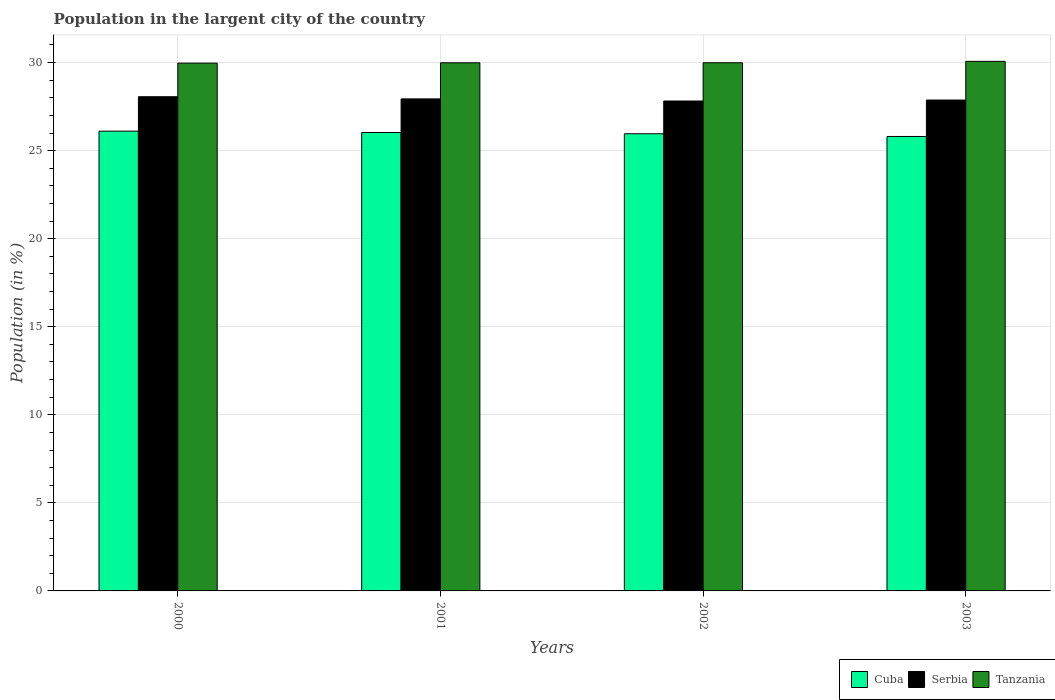How many different coloured bars are there?
Give a very brief answer. 3. Are the number of bars on each tick of the X-axis equal?
Your response must be concise. Yes. How many bars are there on the 2nd tick from the right?
Offer a terse response. 3. What is the label of the 1st group of bars from the left?
Your answer should be very brief. 2000. What is the percentage of population in the largent city in Cuba in 2000?
Offer a terse response. 26.11. Across all years, what is the maximum percentage of population in the largent city in Tanzania?
Your answer should be compact. 30.07. Across all years, what is the minimum percentage of population in the largent city in Tanzania?
Ensure brevity in your answer.  29.97. What is the total percentage of population in the largent city in Serbia in the graph?
Offer a terse response. 111.69. What is the difference between the percentage of population in the largent city in Serbia in 2002 and that in 2003?
Keep it short and to the point. -0.05. What is the difference between the percentage of population in the largent city in Serbia in 2001 and the percentage of population in the largent city in Cuba in 2002?
Provide a short and direct response. 1.98. What is the average percentage of population in the largent city in Cuba per year?
Ensure brevity in your answer.  25.97. In the year 2000, what is the difference between the percentage of population in the largent city in Tanzania and percentage of population in the largent city in Serbia?
Offer a terse response. 1.91. What is the ratio of the percentage of population in the largent city in Tanzania in 2001 to that in 2002?
Your answer should be very brief. 1. Is the difference between the percentage of population in the largent city in Tanzania in 2000 and 2003 greater than the difference between the percentage of population in the largent city in Serbia in 2000 and 2003?
Offer a very short reply. No. What is the difference between the highest and the second highest percentage of population in the largent city in Serbia?
Keep it short and to the point. 0.12. What is the difference between the highest and the lowest percentage of population in the largent city in Serbia?
Provide a short and direct response. 0.24. Is the sum of the percentage of population in the largent city in Tanzania in 2000 and 2003 greater than the maximum percentage of population in the largent city in Serbia across all years?
Ensure brevity in your answer.  Yes. What does the 3rd bar from the left in 2001 represents?
Keep it short and to the point. Tanzania. What does the 1st bar from the right in 2002 represents?
Offer a very short reply. Tanzania. What is the difference between two consecutive major ticks on the Y-axis?
Offer a terse response. 5. Are the values on the major ticks of Y-axis written in scientific E-notation?
Provide a succinct answer. No. How are the legend labels stacked?
Your answer should be very brief. Horizontal. What is the title of the graph?
Make the answer very short. Population in the largent city of the country. Does "Sub-Saharan Africa (all income levels)" appear as one of the legend labels in the graph?
Offer a very short reply. No. What is the label or title of the X-axis?
Offer a terse response. Years. What is the Population (in %) in Cuba in 2000?
Make the answer very short. 26.11. What is the Population (in %) in Serbia in 2000?
Offer a terse response. 28.06. What is the Population (in %) in Tanzania in 2000?
Provide a short and direct response. 29.97. What is the Population (in %) of Cuba in 2001?
Offer a very short reply. 26.03. What is the Population (in %) of Serbia in 2001?
Give a very brief answer. 27.94. What is the Population (in %) of Tanzania in 2001?
Provide a short and direct response. 29.99. What is the Population (in %) in Cuba in 2002?
Your answer should be very brief. 25.96. What is the Population (in %) in Serbia in 2002?
Provide a short and direct response. 27.82. What is the Population (in %) of Tanzania in 2002?
Provide a short and direct response. 29.99. What is the Population (in %) in Cuba in 2003?
Offer a terse response. 25.8. What is the Population (in %) of Serbia in 2003?
Make the answer very short. 27.87. What is the Population (in %) in Tanzania in 2003?
Your response must be concise. 30.07. Across all years, what is the maximum Population (in %) of Cuba?
Your answer should be very brief. 26.11. Across all years, what is the maximum Population (in %) of Serbia?
Ensure brevity in your answer.  28.06. Across all years, what is the maximum Population (in %) in Tanzania?
Make the answer very short. 30.07. Across all years, what is the minimum Population (in %) of Cuba?
Your answer should be very brief. 25.8. Across all years, what is the minimum Population (in %) in Serbia?
Provide a succinct answer. 27.82. Across all years, what is the minimum Population (in %) in Tanzania?
Keep it short and to the point. 29.97. What is the total Population (in %) of Cuba in the graph?
Your response must be concise. 103.9. What is the total Population (in %) in Serbia in the graph?
Provide a succinct answer. 111.69. What is the total Population (in %) in Tanzania in the graph?
Your response must be concise. 120.01. What is the difference between the Population (in %) in Cuba in 2000 and that in 2001?
Provide a succinct answer. 0.08. What is the difference between the Population (in %) in Serbia in 2000 and that in 2001?
Ensure brevity in your answer.  0.12. What is the difference between the Population (in %) of Tanzania in 2000 and that in 2001?
Your answer should be very brief. -0.02. What is the difference between the Population (in %) of Cuba in 2000 and that in 2002?
Your response must be concise. 0.15. What is the difference between the Population (in %) in Serbia in 2000 and that in 2002?
Ensure brevity in your answer.  0.24. What is the difference between the Population (in %) of Tanzania in 2000 and that in 2002?
Give a very brief answer. -0.02. What is the difference between the Population (in %) in Cuba in 2000 and that in 2003?
Make the answer very short. 0.3. What is the difference between the Population (in %) in Serbia in 2000 and that in 2003?
Offer a terse response. 0.19. What is the difference between the Population (in %) of Tanzania in 2000 and that in 2003?
Your answer should be compact. -0.1. What is the difference between the Population (in %) in Cuba in 2001 and that in 2002?
Provide a succinct answer. 0.07. What is the difference between the Population (in %) in Serbia in 2001 and that in 2002?
Your response must be concise. 0.12. What is the difference between the Population (in %) in Tanzania in 2001 and that in 2002?
Your answer should be very brief. -0. What is the difference between the Population (in %) of Cuba in 2001 and that in 2003?
Offer a terse response. 0.23. What is the difference between the Population (in %) in Serbia in 2001 and that in 2003?
Give a very brief answer. 0.06. What is the difference between the Population (in %) in Tanzania in 2001 and that in 2003?
Your answer should be very brief. -0.08. What is the difference between the Population (in %) of Cuba in 2002 and that in 2003?
Offer a terse response. 0.16. What is the difference between the Population (in %) in Serbia in 2002 and that in 2003?
Your response must be concise. -0.05. What is the difference between the Population (in %) of Tanzania in 2002 and that in 2003?
Give a very brief answer. -0.08. What is the difference between the Population (in %) in Cuba in 2000 and the Population (in %) in Serbia in 2001?
Keep it short and to the point. -1.83. What is the difference between the Population (in %) of Cuba in 2000 and the Population (in %) of Tanzania in 2001?
Ensure brevity in your answer.  -3.88. What is the difference between the Population (in %) in Serbia in 2000 and the Population (in %) in Tanzania in 2001?
Give a very brief answer. -1.93. What is the difference between the Population (in %) in Cuba in 2000 and the Population (in %) in Serbia in 2002?
Provide a succinct answer. -1.71. What is the difference between the Population (in %) of Cuba in 2000 and the Population (in %) of Tanzania in 2002?
Provide a succinct answer. -3.88. What is the difference between the Population (in %) in Serbia in 2000 and the Population (in %) in Tanzania in 2002?
Your answer should be compact. -1.93. What is the difference between the Population (in %) in Cuba in 2000 and the Population (in %) in Serbia in 2003?
Ensure brevity in your answer.  -1.77. What is the difference between the Population (in %) in Cuba in 2000 and the Population (in %) in Tanzania in 2003?
Offer a very short reply. -3.96. What is the difference between the Population (in %) of Serbia in 2000 and the Population (in %) of Tanzania in 2003?
Your response must be concise. -2.01. What is the difference between the Population (in %) in Cuba in 2001 and the Population (in %) in Serbia in 2002?
Make the answer very short. -1.79. What is the difference between the Population (in %) of Cuba in 2001 and the Population (in %) of Tanzania in 2002?
Ensure brevity in your answer.  -3.96. What is the difference between the Population (in %) of Serbia in 2001 and the Population (in %) of Tanzania in 2002?
Your response must be concise. -2.05. What is the difference between the Population (in %) in Cuba in 2001 and the Population (in %) in Serbia in 2003?
Ensure brevity in your answer.  -1.84. What is the difference between the Population (in %) of Cuba in 2001 and the Population (in %) of Tanzania in 2003?
Keep it short and to the point. -4.04. What is the difference between the Population (in %) of Serbia in 2001 and the Population (in %) of Tanzania in 2003?
Provide a short and direct response. -2.13. What is the difference between the Population (in %) in Cuba in 2002 and the Population (in %) in Serbia in 2003?
Offer a terse response. -1.91. What is the difference between the Population (in %) of Cuba in 2002 and the Population (in %) of Tanzania in 2003?
Your answer should be very brief. -4.11. What is the difference between the Population (in %) in Serbia in 2002 and the Population (in %) in Tanzania in 2003?
Offer a very short reply. -2.25. What is the average Population (in %) in Cuba per year?
Keep it short and to the point. 25.97. What is the average Population (in %) in Serbia per year?
Provide a succinct answer. 27.92. What is the average Population (in %) in Tanzania per year?
Make the answer very short. 30. In the year 2000, what is the difference between the Population (in %) of Cuba and Population (in %) of Serbia?
Give a very brief answer. -1.95. In the year 2000, what is the difference between the Population (in %) in Cuba and Population (in %) in Tanzania?
Your response must be concise. -3.86. In the year 2000, what is the difference between the Population (in %) of Serbia and Population (in %) of Tanzania?
Your answer should be compact. -1.91. In the year 2001, what is the difference between the Population (in %) in Cuba and Population (in %) in Serbia?
Your answer should be very brief. -1.91. In the year 2001, what is the difference between the Population (in %) in Cuba and Population (in %) in Tanzania?
Keep it short and to the point. -3.96. In the year 2001, what is the difference between the Population (in %) in Serbia and Population (in %) in Tanzania?
Offer a terse response. -2.05. In the year 2002, what is the difference between the Population (in %) in Cuba and Population (in %) in Serbia?
Make the answer very short. -1.86. In the year 2002, what is the difference between the Population (in %) in Cuba and Population (in %) in Tanzania?
Give a very brief answer. -4.03. In the year 2002, what is the difference between the Population (in %) of Serbia and Population (in %) of Tanzania?
Make the answer very short. -2.17. In the year 2003, what is the difference between the Population (in %) in Cuba and Population (in %) in Serbia?
Keep it short and to the point. -2.07. In the year 2003, what is the difference between the Population (in %) in Cuba and Population (in %) in Tanzania?
Offer a very short reply. -4.27. In the year 2003, what is the difference between the Population (in %) of Serbia and Population (in %) of Tanzania?
Your response must be concise. -2.2. What is the ratio of the Population (in %) in Serbia in 2000 to that in 2001?
Offer a very short reply. 1. What is the ratio of the Population (in %) in Cuba in 2000 to that in 2002?
Keep it short and to the point. 1.01. What is the ratio of the Population (in %) in Serbia in 2000 to that in 2002?
Offer a terse response. 1.01. What is the ratio of the Population (in %) of Cuba in 2000 to that in 2003?
Offer a very short reply. 1.01. What is the ratio of the Population (in %) of Serbia in 2000 to that in 2003?
Your answer should be compact. 1.01. What is the ratio of the Population (in %) in Cuba in 2001 to that in 2002?
Make the answer very short. 1. What is the ratio of the Population (in %) in Serbia in 2001 to that in 2002?
Offer a very short reply. 1. What is the ratio of the Population (in %) in Tanzania in 2001 to that in 2002?
Your answer should be compact. 1. What is the ratio of the Population (in %) in Cuba in 2001 to that in 2003?
Provide a succinct answer. 1.01. What is the ratio of the Population (in %) of Serbia in 2001 to that in 2003?
Offer a terse response. 1. What is the ratio of the Population (in %) of Cuba in 2002 to that in 2003?
Provide a succinct answer. 1.01. What is the ratio of the Population (in %) of Serbia in 2002 to that in 2003?
Your response must be concise. 1. What is the difference between the highest and the second highest Population (in %) of Cuba?
Your answer should be compact. 0.08. What is the difference between the highest and the second highest Population (in %) of Serbia?
Offer a very short reply. 0.12. What is the difference between the highest and the second highest Population (in %) of Tanzania?
Your answer should be very brief. 0.08. What is the difference between the highest and the lowest Population (in %) of Cuba?
Provide a short and direct response. 0.3. What is the difference between the highest and the lowest Population (in %) of Serbia?
Offer a terse response. 0.24. What is the difference between the highest and the lowest Population (in %) in Tanzania?
Provide a succinct answer. 0.1. 